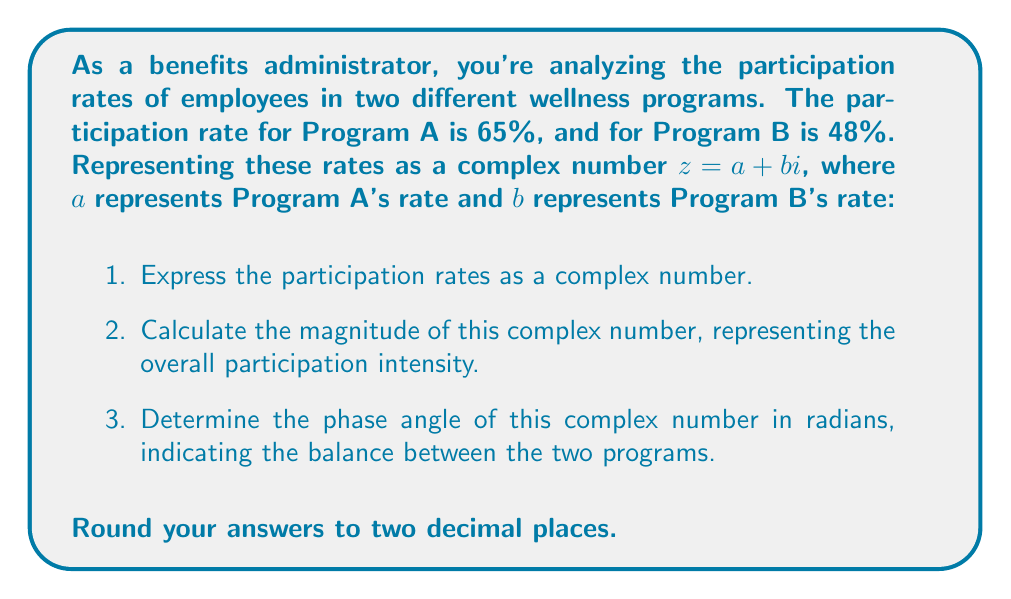Give your solution to this math problem. Let's approach this step-by-step:

1. Expressing the participation rates as a complex number:
   $z = 65 + 48i$

2. Calculating the magnitude:
   The magnitude of a complex number $z = a + bi$ is given by the formula:
   $$|z| = \sqrt{a^2 + b^2}$$
   
   In this case:
   $$|z| = \sqrt{65^2 + 48^2} = \sqrt{4225 + 2304} = \sqrt{6529} \approx 80.80$$

3. Determining the phase angle:
   The phase angle $\theta$ of a complex number $z = a + bi$ is given by:
   $$\theta = \tan^{-1}\left(\frac{b}{a}\right)$$
   
   Here:
   $$\theta = \tan^{-1}\left(\frac{48}{65}\right) \approx 0.64$$ radians

The magnitude (80.80) represents the overall intensity of participation across both programs. A higher magnitude indicates higher overall participation.

The phase angle (0.64 radians) represents the balance between the two programs. An angle closer to $\frac{\pi}{4}$ (about 0.79 radians) would indicate more balanced participation, while an angle closer to 0 would indicate higher participation in Program A relative to Program B.
Answer: 1. Complex number: $z = 65 + 48i$
2. Magnitude: $|z| \approx 80.80$
3. Phase angle: $\theta \approx 0.64$ radians 